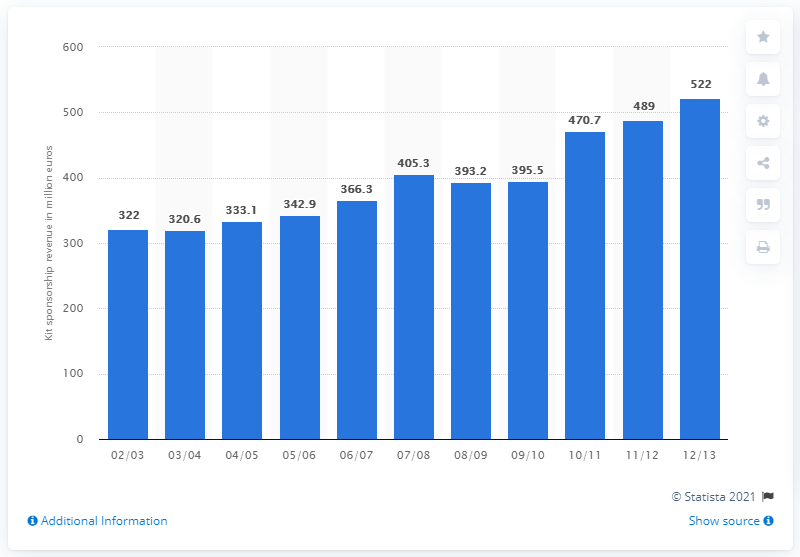Draw attention to some important aspects in this diagram. The total revenue from kit sponsorships in the 2004/05 season was 333.1 million. 